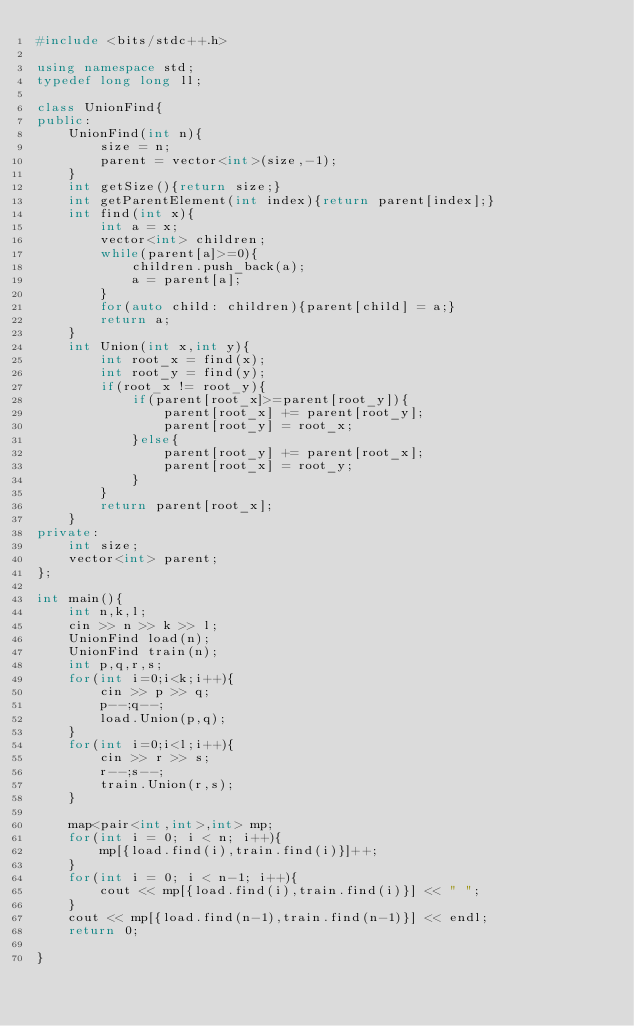<code> <loc_0><loc_0><loc_500><loc_500><_C++_>#include <bits/stdc++.h>

using namespace std;
typedef long long ll;

class UnionFind{
public:
    UnionFind(int n){
        size = n;
        parent = vector<int>(size,-1);
    }
    int getSize(){return size;}
    int getParentElement(int index){return parent[index];}
    int find(int x){
        int a = x;
        vector<int> children;
        while(parent[a]>=0){
            children.push_back(a);
            a = parent[a];
        }
        for(auto child: children){parent[child] = a;}
        return a;
    }
    int Union(int x,int y){
        int root_x = find(x);
        int root_y = find(y);
        if(root_x != root_y){
            if(parent[root_x]>=parent[root_y]){
                parent[root_x] += parent[root_y];
                parent[root_y] = root_x;
            }else{
                parent[root_y] += parent[root_x];
                parent[root_x] = root_y;
            }
        }
        return parent[root_x];
    }
private:
    int size;
    vector<int> parent;
};

int main(){
    int n,k,l;
    cin >> n >> k >> l;
    UnionFind load(n);
    UnionFind train(n);
    int p,q,r,s;
    for(int i=0;i<k;i++){
        cin >> p >> q;
        p--;q--;
        load.Union(p,q);
    }
    for(int i=0;i<l;i++){
        cin >> r >> s;
        r--;s--;
        train.Union(r,s);
    }

    map<pair<int,int>,int> mp;
    for(int i = 0; i < n; i++){
        mp[{load.find(i),train.find(i)}]++;
    }
    for(int i = 0; i < n-1; i++){
        cout << mp[{load.find(i),train.find(i)}] << " ";
    }
    cout << mp[{load.find(n-1),train.find(n-1)}] << endl;
    return 0;

}
</code> 